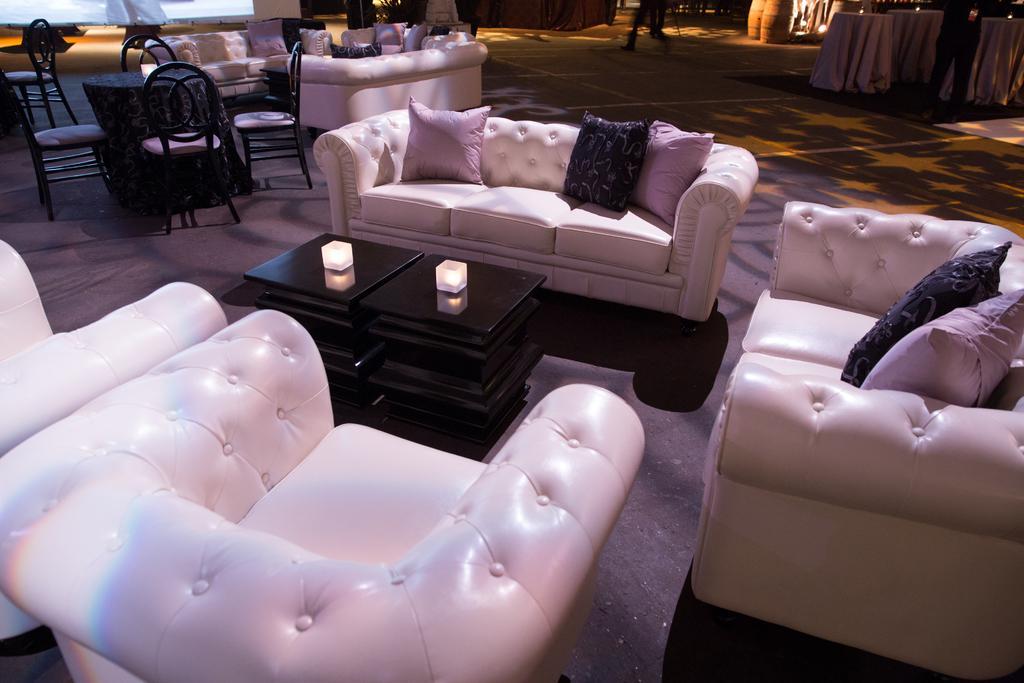In one or two sentences, can you explain what this image depicts? In this picture we can see the inside view of a hall. These are the sofas and there are pillows. Here we can see a table and there are lights. 